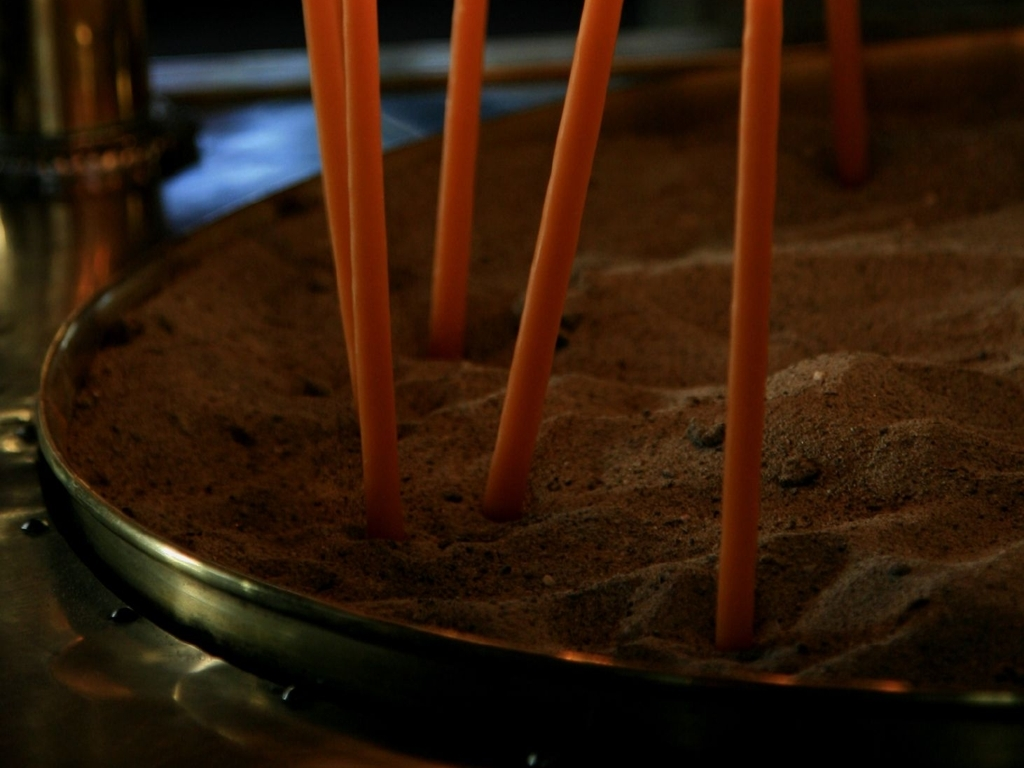What is the lighting condition in the image? The lighting in the image is subtle and low-key, creating soft shadows and highlights that accentuate the texture of the sand and the smooth, cylindrical shapes of the candles. It suggests an intimate and serene setting, possibly for a tranquil or meditative purpose. 